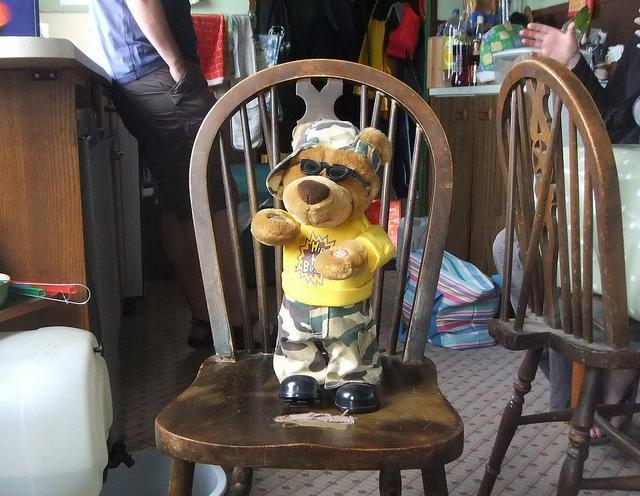What style of pants are these?
Indicate the correct response by choosing from the four available options to answer the question.
Options: White wash, stripped, camo, polka-dot. Camo. 